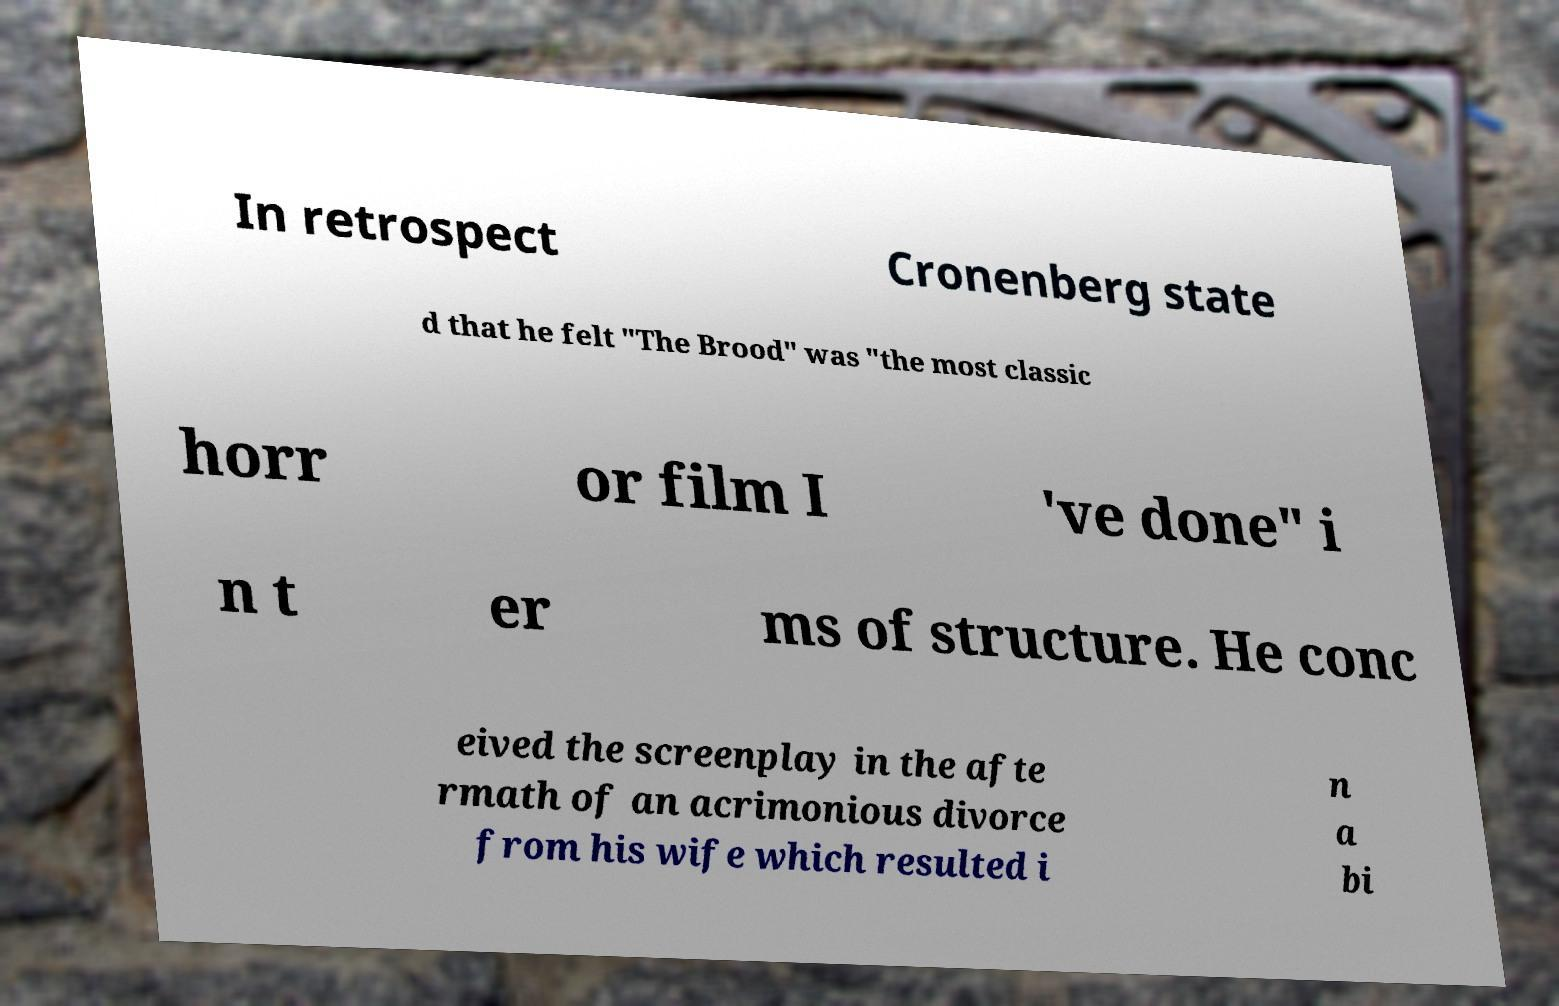Can you accurately transcribe the text from the provided image for me? In retrospect Cronenberg state d that he felt "The Brood" was "the most classic horr or film I 've done" i n t er ms of structure. He conc eived the screenplay in the afte rmath of an acrimonious divorce from his wife which resulted i n a bi 